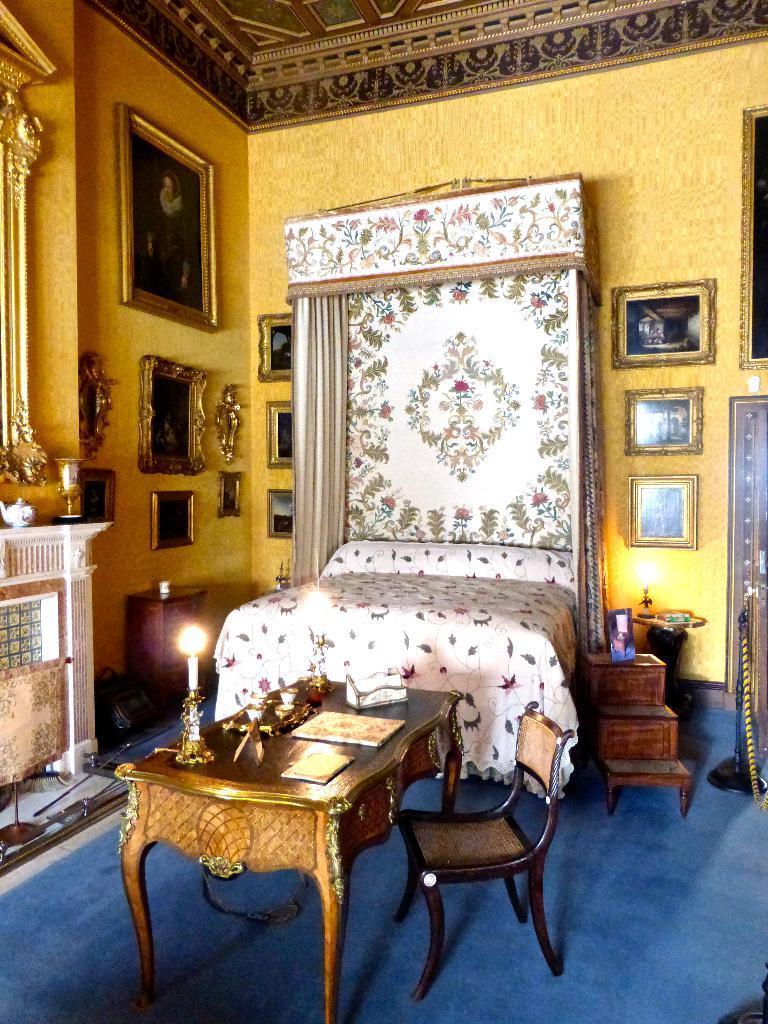Describe this image in one or two sentences. In this image I can see a table and chair, on the table I can see a candle, books, papers. Background I can see bed, on the bed there is a blanket in white color. I can also see few frames attached to the wall and the wall is in yellow color. 